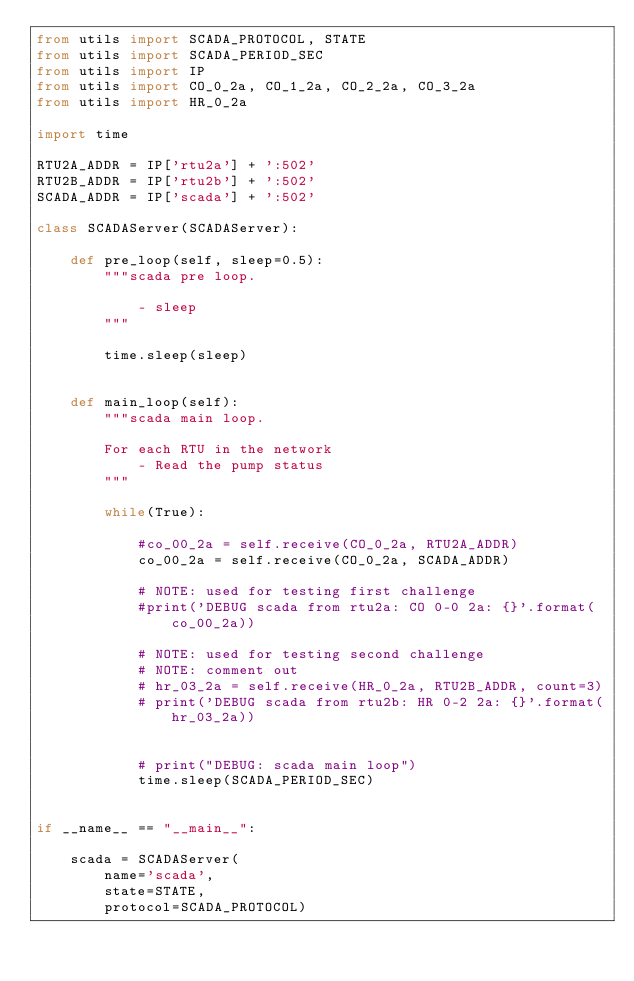<code> <loc_0><loc_0><loc_500><loc_500><_Python_>from utils import SCADA_PROTOCOL, STATE
from utils import SCADA_PERIOD_SEC
from utils import IP
from utils import CO_0_2a, CO_1_2a, CO_2_2a, CO_3_2a
from utils import HR_0_2a

import time

RTU2A_ADDR = IP['rtu2a'] + ':502'
RTU2B_ADDR = IP['rtu2b'] + ':502'
SCADA_ADDR = IP['scada'] + ':502'

class SCADAServer(SCADAServer):

    def pre_loop(self, sleep=0.5):
        """scada pre loop.

            - sleep
        """

        time.sleep(sleep)


    def main_loop(self):
        """scada main loop.

        For each RTU in the network
            - Read the pump status
        """

        while(True):

            #co_00_2a = self.receive(CO_0_2a, RTU2A_ADDR)
            co_00_2a = self.receive(CO_0_2a, SCADA_ADDR)

            # NOTE: used for testing first challenge
            #print('DEBUG scada from rtu2a: CO 0-0 2a: {}'.format(co_00_2a))

            # NOTE: used for testing second challenge
            # NOTE: comment out
            # hr_03_2a = self.receive(HR_0_2a, RTU2B_ADDR, count=3)
            # print('DEBUG scada from rtu2b: HR 0-2 2a: {}'.format(hr_03_2a))


            # print("DEBUG: scada main loop")
            time.sleep(SCADA_PERIOD_SEC)


if __name__ == "__main__":

    scada = SCADAServer(
        name='scada',
        state=STATE,
        protocol=SCADA_PROTOCOL)
</code> 